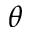Convert formula to latex. <formula><loc_0><loc_0><loc_500><loc_500>\theta</formula> 